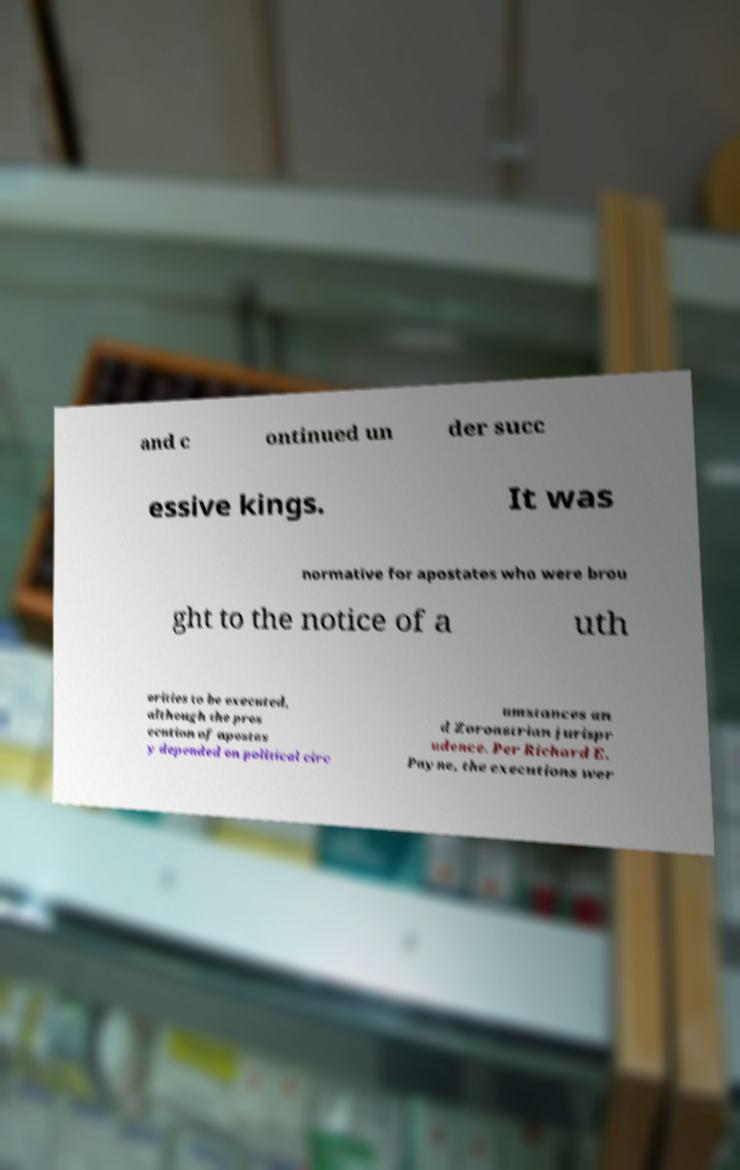Can you read and provide the text displayed in the image?This photo seems to have some interesting text. Can you extract and type it out for me? and c ontinued un der succ essive kings. It was normative for apostates who were brou ght to the notice of a uth orities to be executed, although the pros ecution of apostas y depended on political circ umstances an d Zoroastrian jurispr udence. Per Richard E. Payne, the executions wer 